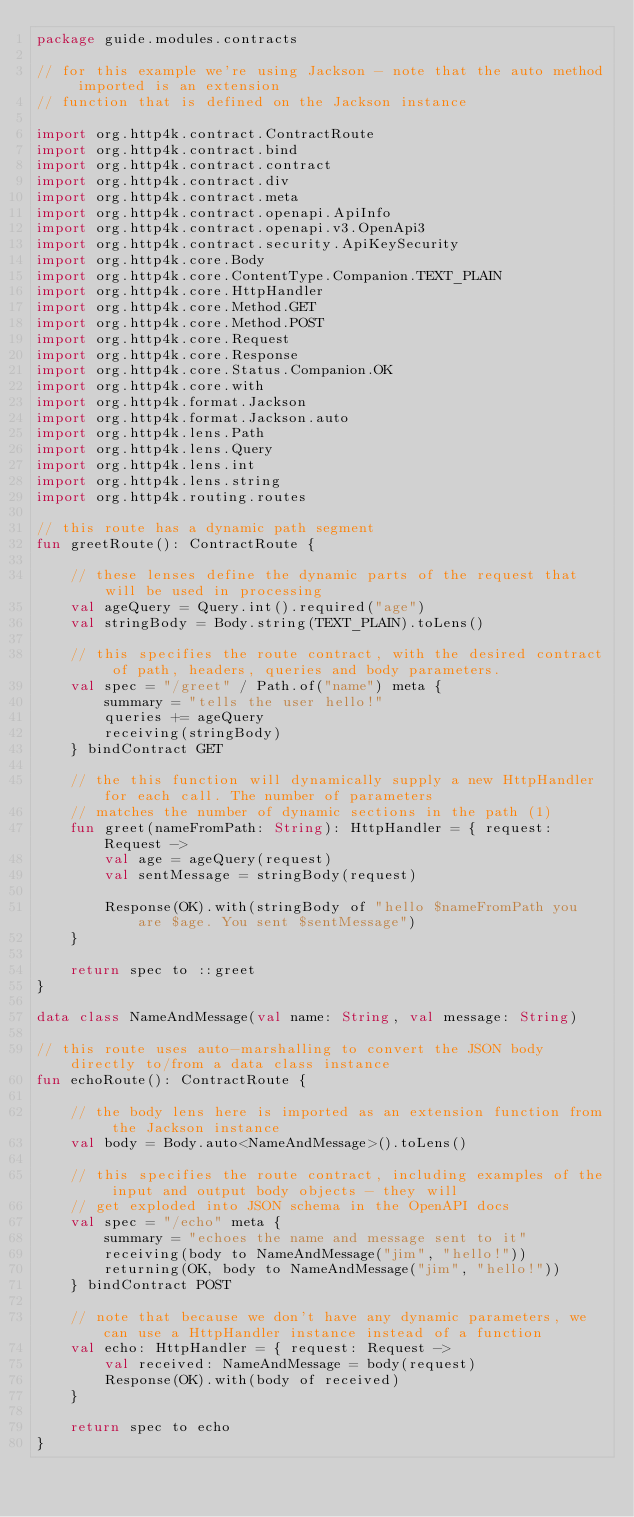<code> <loc_0><loc_0><loc_500><loc_500><_Kotlin_>package guide.modules.contracts

// for this example we're using Jackson - note that the auto method imported is an extension
// function that is defined on the Jackson instance

import org.http4k.contract.ContractRoute
import org.http4k.contract.bind
import org.http4k.contract.contract
import org.http4k.contract.div
import org.http4k.contract.meta
import org.http4k.contract.openapi.ApiInfo
import org.http4k.contract.openapi.v3.OpenApi3
import org.http4k.contract.security.ApiKeySecurity
import org.http4k.core.Body
import org.http4k.core.ContentType.Companion.TEXT_PLAIN
import org.http4k.core.HttpHandler
import org.http4k.core.Method.GET
import org.http4k.core.Method.POST
import org.http4k.core.Request
import org.http4k.core.Response
import org.http4k.core.Status.Companion.OK
import org.http4k.core.with
import org.http4k.format.Jackson
import org.http4k.format.Jackson.auto
import org.http4k.lens.Path
import org.http4k.lens.Query
import org.http4k.lens.int
import org.http4k.lens.string
import org.http4k.routing.routes

// this route has a dynamic path segment
fun greetRoute(): ContractRoute {

    // these lenses define the dynamic parts of the request that will be used in processing
    val ageQuery = Query.int().required("age")
    val stringBody = Body.string(TEXT_PLAIN).toLens()

    // this specifies the route contract, with the desired contract of path, headers, queries and body parameters.
    val spec = "/greet" / Path.of("name") meta {
        summary = "tells the user hello!"
        queries += ageQuery
        receiving(stringBody)
    } bindContract GET

    // the this function will dynamically supply a new HttpHandler for each call. The number of parameters
    // matches the number of dynamic sections in the path (1)
    fun greet(nameFromPath: String): HttpHandler = { request: Request ->
        val age = ageQuery(request)
        val sentMessage = stringBody(request)

        Response(OK).with(stringBody of "hello $nameFromPath you are $age. You sent $sentMessage")
    }

    return spec to ::greet
}

data class NameAndMessage(val name: String, val message: String)

// this route uses auto-marshalling to convert the JSON body directly to/from a data class instance
fun echoRoute(): ContractRoute {

    // the body lens here is imported as an extension function from the Jackson instance
    val body = Body.auto<NameAndMessage>().toLens()

    // this specifies the route contract, including examples of the input and output body objects - they will
    // get exploded into JSON schema in the OpenAPI docs
    val spec = "/echo" meta {
        summary = "echoes the name and message sent to it"
        receiving(body to NameAndMessage("jim", "hello!"))
        returning(OK, body to NameAndMessage("jim", "hello!"))
    } bindContract POST

    // note that because we don't have any dynamic parameters, we can use a HttpHandler instance instead of a function
    val echo: HttpHandler = { request: Request ->
        val received: NameAndMessage = body(request)
        Response(OK).with(body of received)
    }

    return spec to echo
}
</code> 